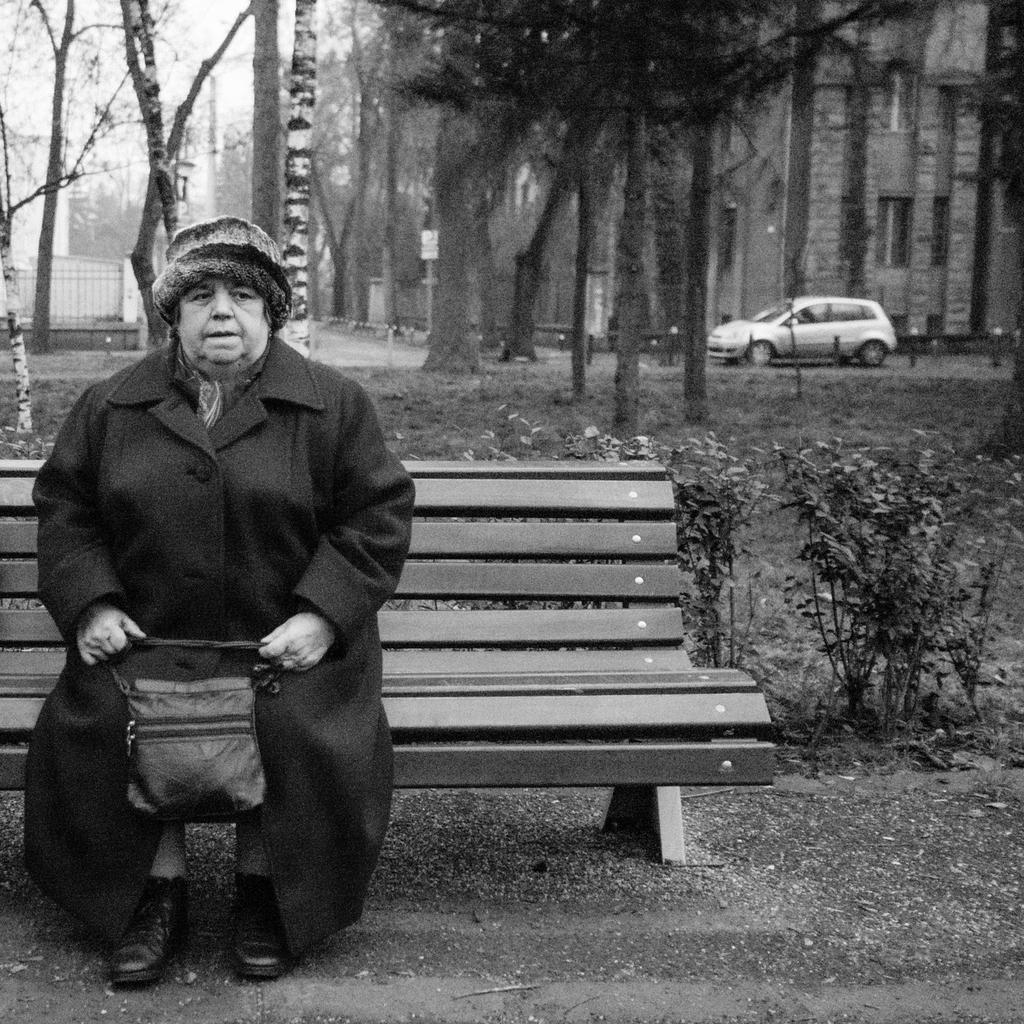Who is present in the image? There is a woman in the image. What is the woman wearing on her head? The woman is wearing a hat. What is the woman's posture in the image? The woman is sitting in a chair. What item is the woman carrying? The woman is carrying a handbag. What can be seen in the background of the image? There are trees, buildings, and a car in the background of the image. What type of brush is the woman using to blow on the trees in the image? There is no brush or blowing action depicted in the image; the woman is simply sitting in a chair with a hat and handbag. 